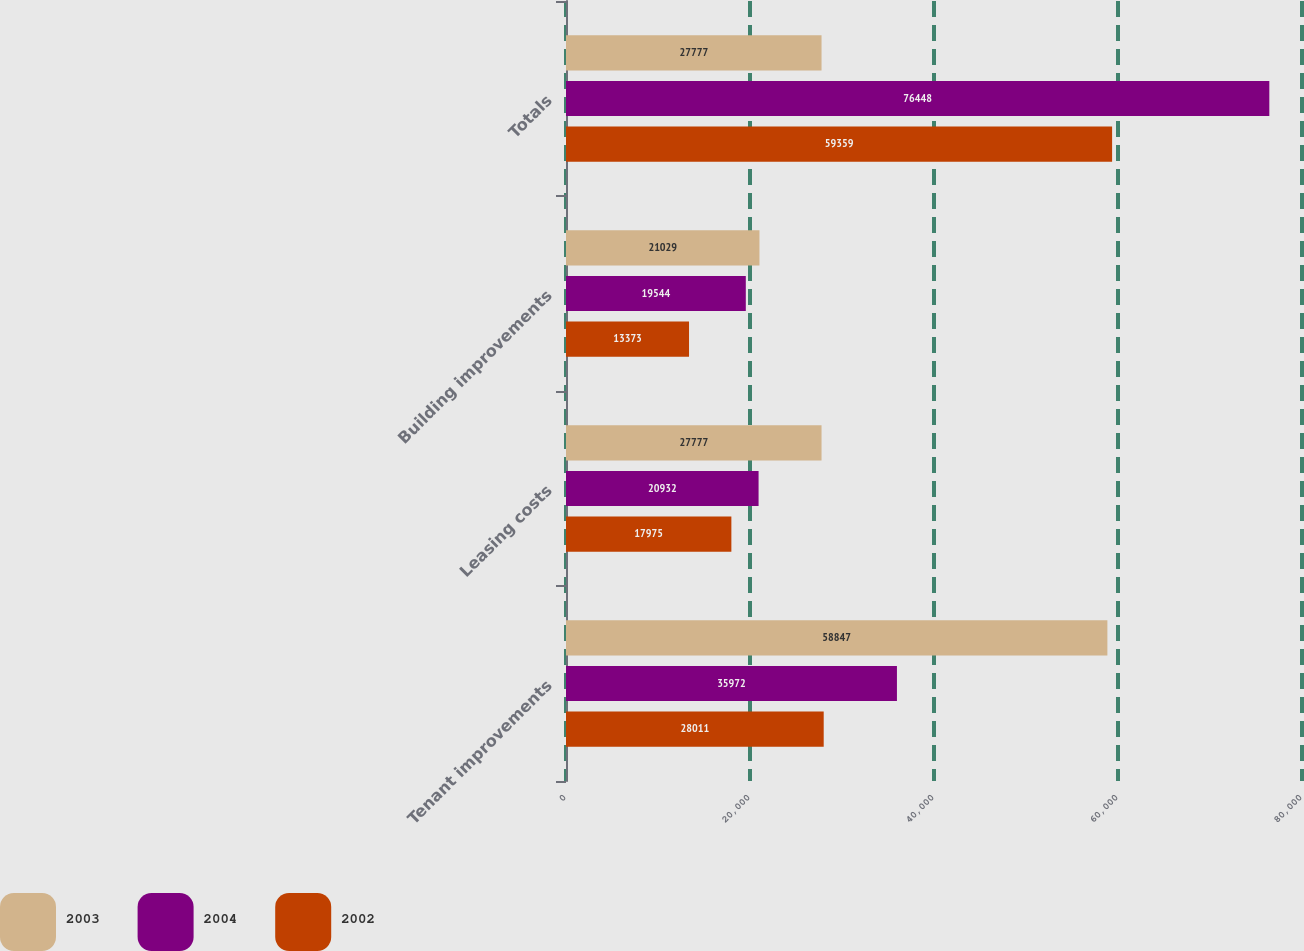Convert chart to OTSL. <chart><loc_0><loc_0><loc_500><loc_500><stacked_bar_chart><ecel><fcel>Tenant improvements<fcel>Leasing costs<fcel>Building improvements<fcel>Totals<nl><fcel>2003<fcel>58847<fcel>27777<fcel>21029<fcel>27777<nl><fcel>2004<fcel>35972<fcel>20932<fcel>19544<fcel>76448<nl><fcel>2002<fcel>28011<fcel>17975<fcel>13373<fcel>59359<nl></chart> 